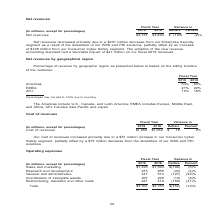According to Nortonlifelock's financial document, What regions are included in the Americas? U.S., Canada, and Latin America. The document states: "The Americas include U.S., Canada, and Latin America; EMEA includes Europe, Middle East, and Africa; APJ includes Asia Pacific and Japan...." Also, What does the table show? Net revenues by geographical region. The document states: "Net revenues by geographical region..." Also, How is geographical location of the customer determined? based on the billing location of the customer. The document states: "evenue by geographic region as presented below is based on the billing location of the customer...." Also, can you calculate: What is the change in percentage of revenue for Americas from fiscal 2018 to 2019? Based on the calculation: 64-63, the result is 1 (percentage). This is based on the information: "Americas 64% 63% EMEA 21% 22% APJ 15% 16% Americas 64% 63% EMEA 21% 22% APJ 15% 16%..." The key data points involved are: 63, 64. Also, can you calculate: What is the change in percentage of revenue for EMEA from fiscal 2018 to 2019? Based on the calculation: 21-22, the result is -1 (percentage). This is based on the information: "Americas 64% 63% EMEA 21% 22% APJ 15% 16% Americas 64% 63% EMEA 21% 22% APJ 15% 16%..." The key data points involved are: 21, 22. Also, can you calculate: What is the change in percentage of revenue for APJ from fiscal 2018 to 2019? Based on the calculation: 15-16, the result is -1 (percentage). This is based on the information: "Americas 64% 63% EMEA 21% 22% APJ 15% 16% Americas 64% 63% EMEA 21% 22% APJ 15% 16%..." The key data points involved are: 15, 16. 